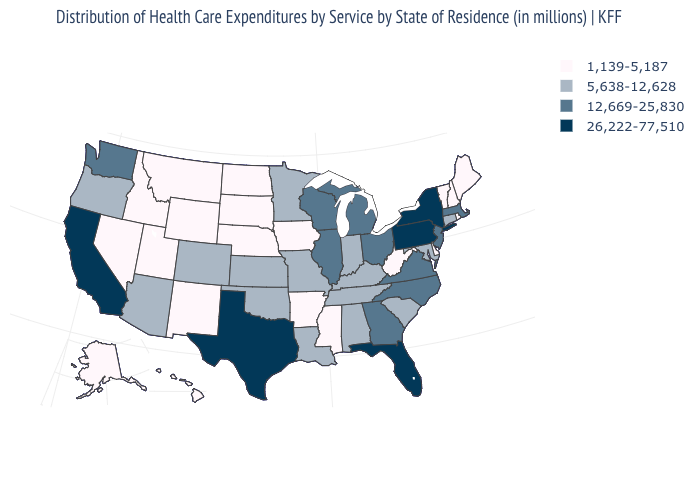Among the states that border Florida , does Georgia have the highest value?
Write a very short answer. Yes. What is the value of Nevada?
Give a very brief answer. 1,139-5,187. Name the states that have a value in the range 5,638-12,628?
Concise answer only. Alabama, Arizona, Colorado, Connecticut, Indiana, Kansas, Kentucky, Louisiana, Maryland, Minnesota, Missouri, Oklahoma, Oregon, South Carolina, Tennessee. Among the states that border Alabama , which have the lowest value?
Quick response, please. Mississippi. Does the first symbol in the legend represent the smallest category?
Concise answer only. Yes. Among the states that border Utah , does Wyoming have the lowest value?
Short answer required. Yes. What is the value of Hawaii?
Keep it brief. 1,139-5,187. Name the states that have a value in the range 26,222-77,510?
Keep it brief. California, Florida, New York, Pennsylvania, Texas. Name the states that have a value in the range 1,139-5,187?
Write a very short answer. Alaska, Arkansas, Delaware, Hawaii, Idaho, Iowa, Maine, Mississippi, Montana, Nebraska, Nevada, New Hampshire, New Mexico, North Dakota, Rhode Island, South Dakota, Utah, Vermont, West Virginia, Wyoming. Does the first symbol in the legend represent the smallest category?
Concise answer only. Yes. Name the states that have a value in the range 26,222-77,510?
Be succinct. California, Florida, New York, Pennsylvania, Texas. Does South Carolina have the same value as Tennessee?
Be succinct. Yes. Name the states that have a value in the range 1,139-5,187?
Be succinct. Alaska, Arkansas, Delaware, Hawaii, Idaho, Iowa, Maine, Mississippi, Montana, Nebraska, Nevada, New Hampshire, New Mexico, North Dakota, Rhode Island, South Dakota, Utah, Vermont, West Virginia, Wyoming. Is the legend a continuous bar?
Write a very short answer. No. What is the value of New Mexico?
Answer briefly. 1,139-5,187. 